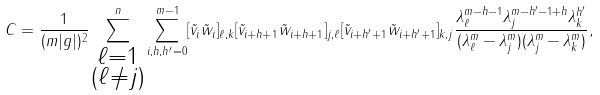<formula> <loc_0><loc_0><loc_500><loc_500>C = \frac { 1 } { ( m | g | ) ^ { 2 } } \sum _ { \substack { \ell = 1 \\ ( \ell \neq j ) } } ^ { n } \sum _ { i , h , h ^ { \prime } = 0 } ^ { m - 1 } [ \tilde { v } _ { i } \tilde { w } _ { i } ] _ { \ell , k } [ \tilde { v } _ { i + h + 1 } \tilde { w } _ { i + h + 1 } ] _ { j , \ell } [ \tilde { v } _ { i + h ^ { \prime } + 1 } \tilde { w } _ { i + h ^ { \prime } + 1 } ] _ { k , j } \frac { \lambda _ { \ell } ^ { m - h - 1 } \lambda _ { j } ^ { m - h ^ { \prime } - 1 + h } \lambda _ { k } ^ { h ^ { \prime } } } { ( \lambda _ { \ell } ^ { m } - \lambda _ { j } ^ { m } ) ( \lambda _ { j } ^ { m } - \lambda _ { k } ^ { m } ) } ,</formula> 